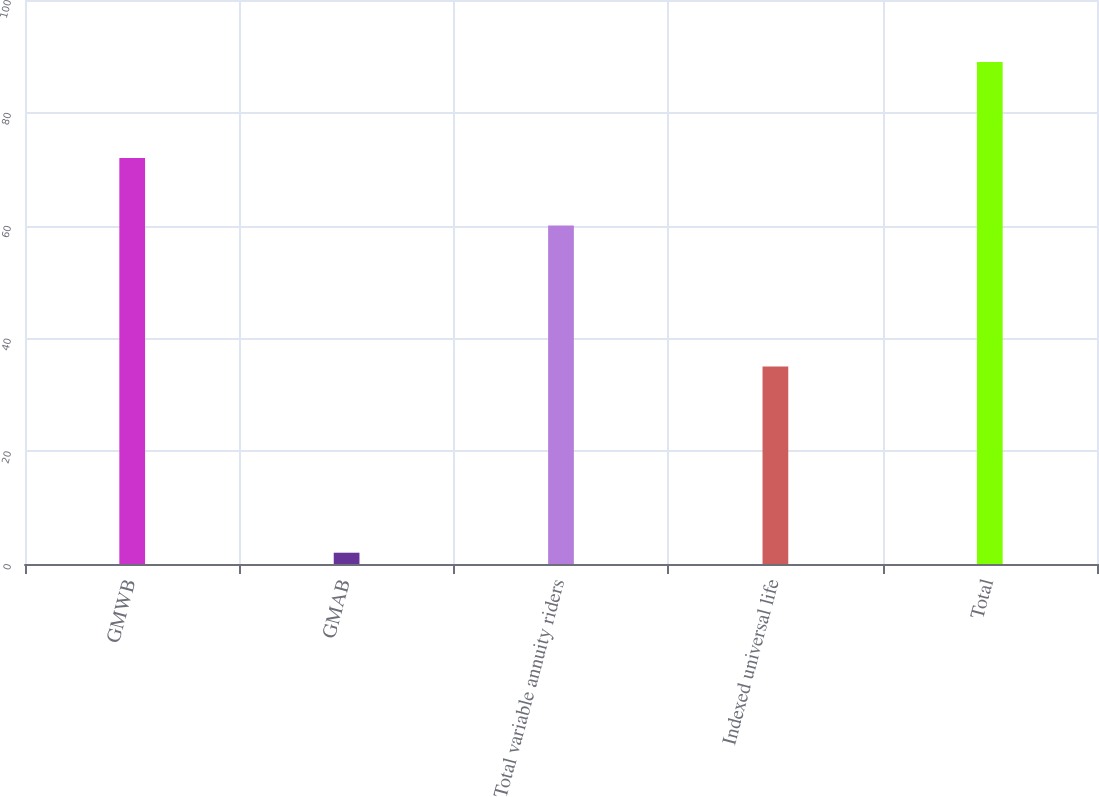Convert chart. <chart><loc_0><loc_0><loc_500><loc_500><bar_chart><fcel>GMWB<fcel>GMAB<fcel>Total variable annuity riders<fcel>Indexed universal life<fcel>Total<nl><fcel>72<fcel>2<fcel>60<fcel>35<fcel>89<nl></chart> 